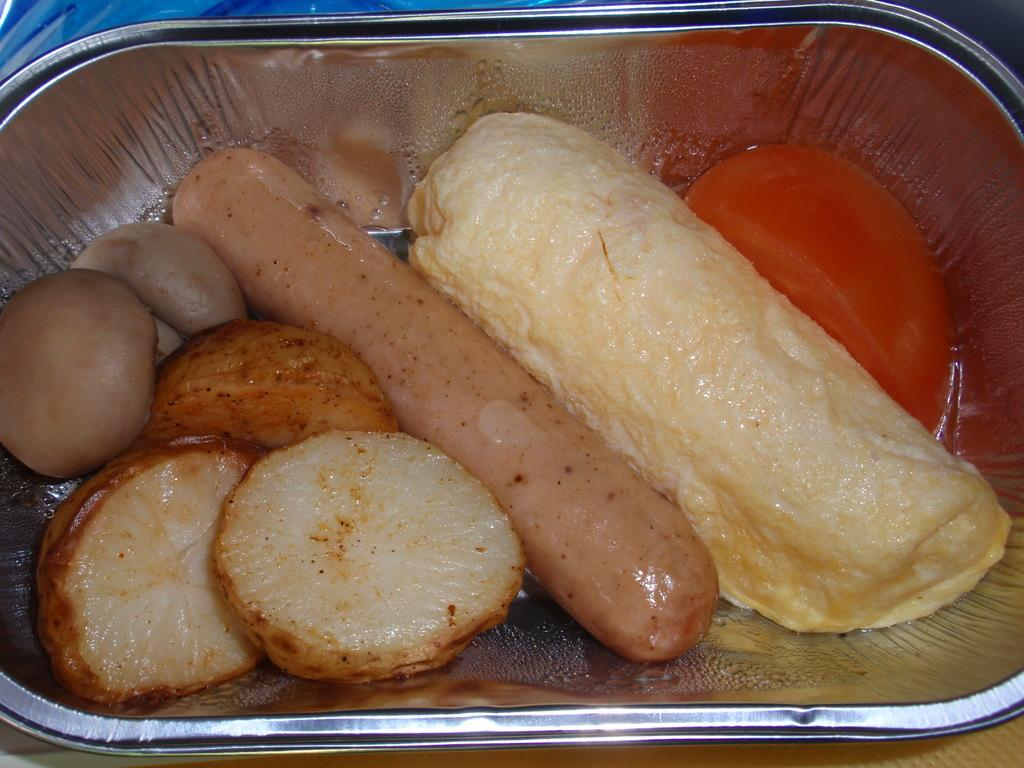What is the main object in the center of the image? There is a box in the center of the image. What is the box placed on? The box is on some object. What type of items can be found inside the box? There are food items in the box. What color is the object at the top of the image? There is a blue color object at the top of the image. How does the duck transport the box in the image? There is no duck present in the image, and therefore no such activity can be observed. 